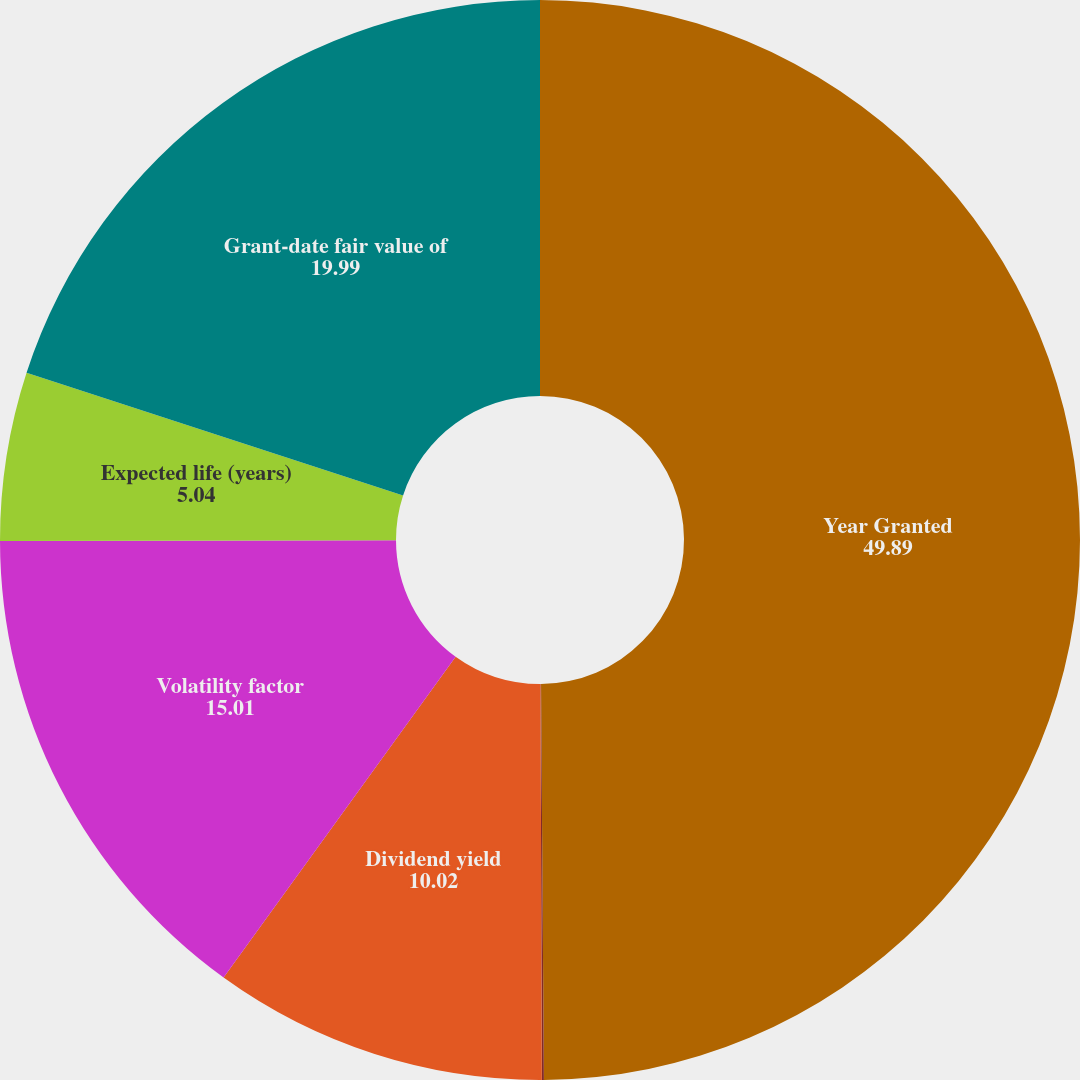Convert chart to OTSL. <chart><loc_0><loc_0><loc_500><loc_500><pie_chart><fcel>Year Granted<fcel>Risk-free interest rate<fcel>Dividend yield<fcel>Volatility factor<fcel>Expected life (years)<fcel>Grant-date fair value of<nl><fcel>49.89%<fcel>0.06%<fcel>10.02%<fcel>15.01%<fcel>5.04%<fcel>19.99%<nl></chart> 